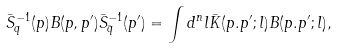Convert formula to latex. <formula><loc_0><loc_0><loc_500><loc_500>\bar { S } _ { q } ^ { - 1 } ( p ) B ( p , p ^ { \prime } ) \bar { S } _ { \bar { q } } ^ { - 1 } ( p ^ { \prime } ) = \int d ^ { n } l \bar { K } ( p . p ^ { \prime } ; l ) B ( p . p ^ { \prime } ; l ) ,</formula> 